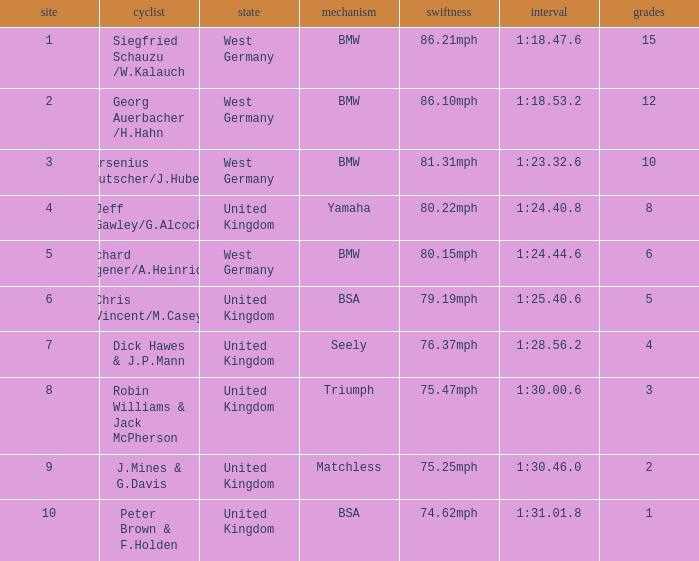Which place has points larger than 1, a bmw machine, and a time of 1:18.47.6? 1.0. 